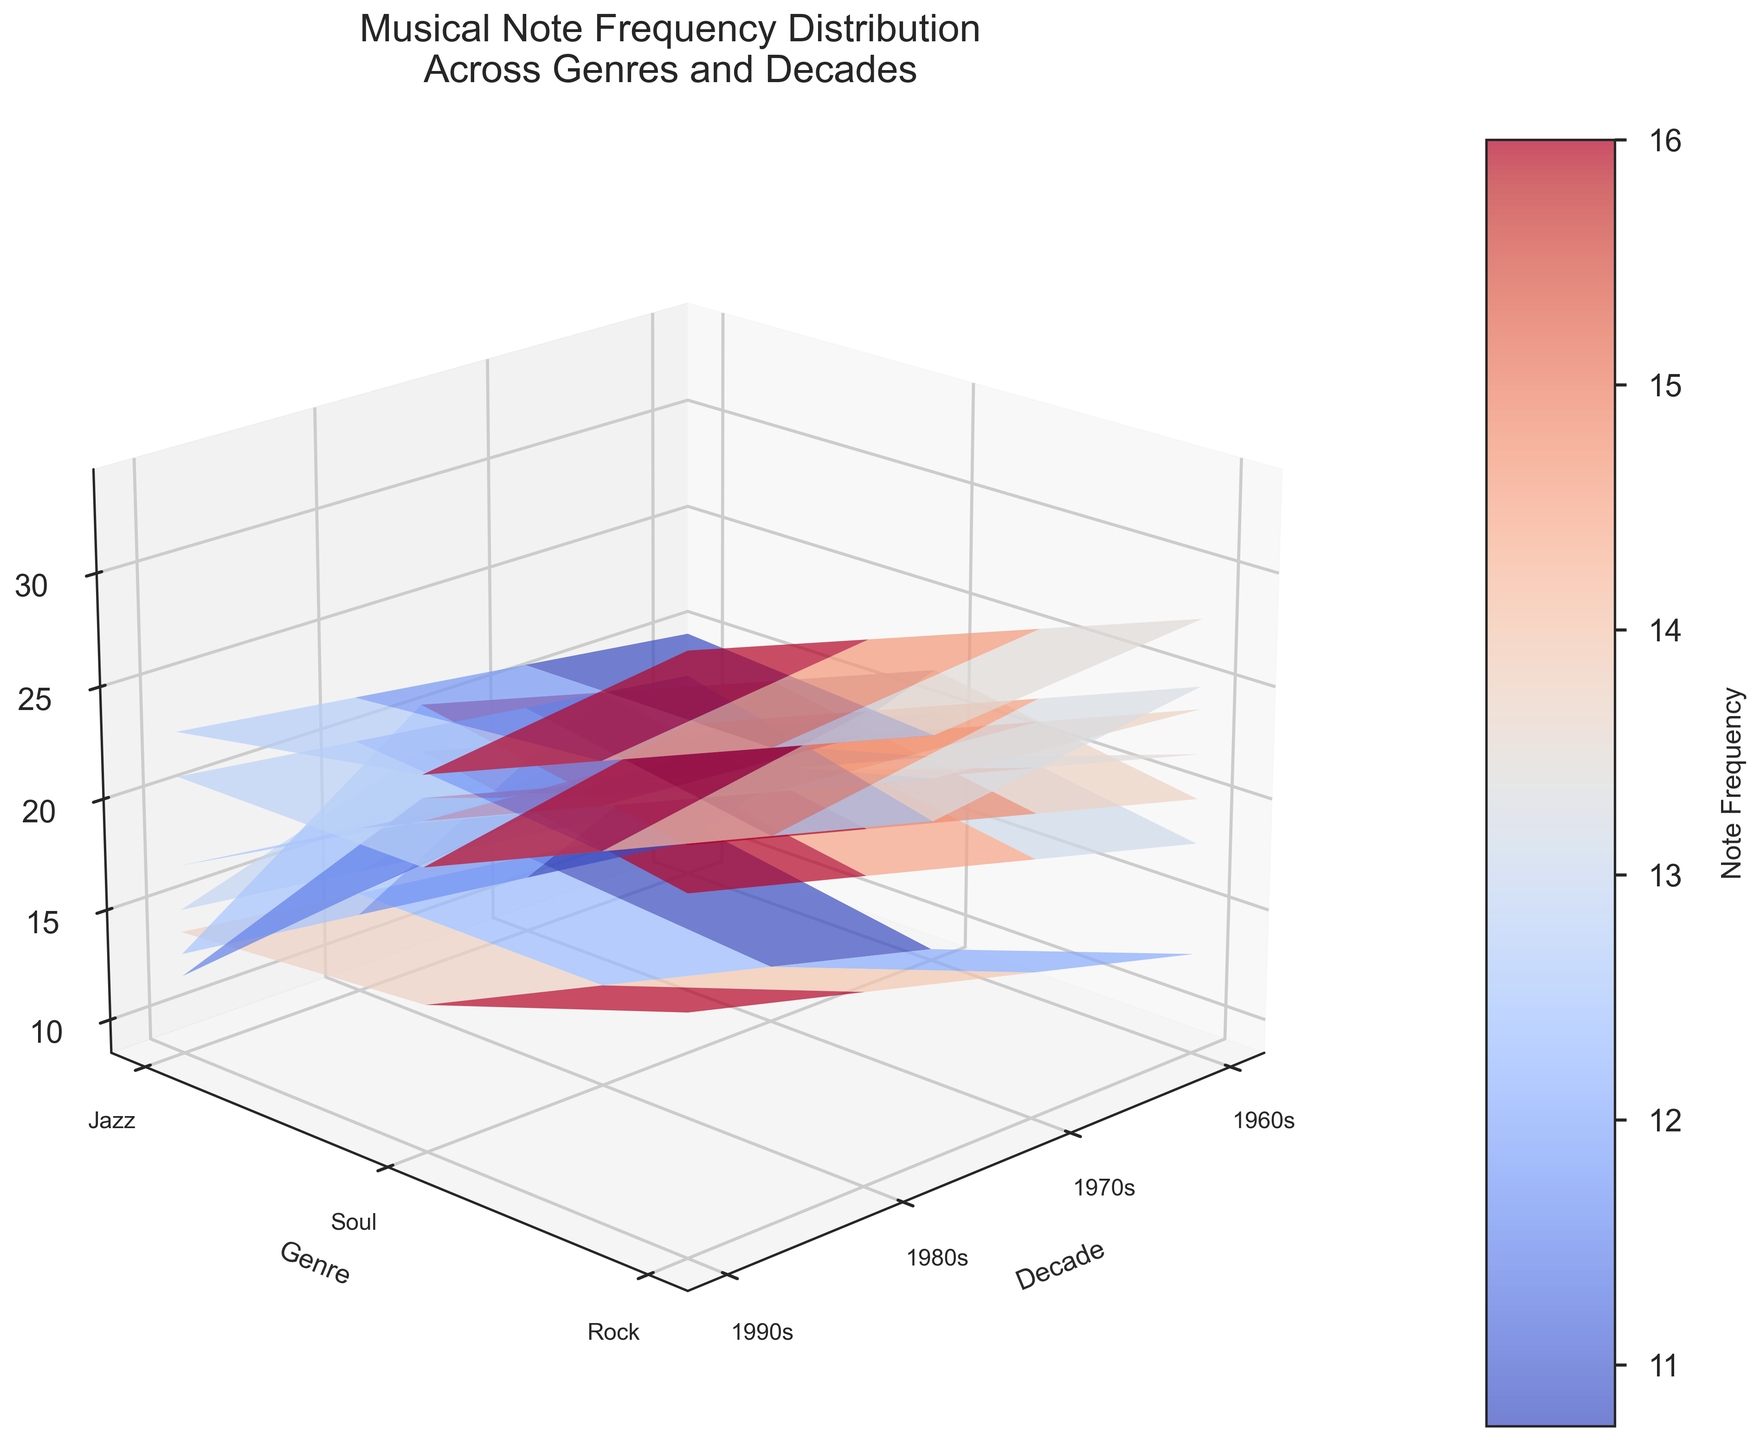What is the title of the figure? The title is usually positioned at the top of the figure. Here, it reads "Musical Note Frequency Distribution Across Genres and Decades".
Answer: Musical Note Frequency Distribution Across Genres and Decades Which genres are displayed in the figure? By looking at the y-axis labels, we can identify the genres. They include Jazz, Soul, and Rock.
Answer: Jazz, Soul, and Rock In which decade does the genre Jazz have the highest 'C' note frequency? By examining the section of the surface plot corresponding to Jazz, we find that the highest 'C' note frequency occurs in the 1960s.
Answer: 1960s How does the frequency of the 'A' note in Soul music change from the 1960s to the 1990s? By analyzing the change in the 'A' note frequencies for Soul across the years (24 in the 1960s, 26 in the 1970s, 28 in the 1980s, and 30 in the 1990s), we see a gradual increase.
Answer: Increases Which decade has the highest overall frequency for the 'G' note across all genres? We need to look at the surface corresponding to the 'G' note and identify which decade has the highest peaks across all genres. The highest frequency appears in the 1990s.
Answer: 1990s How does the frequency of the 'F' note in Rock music compare between the 1980s and the 1990s? By examining the 'F' note frequencies for Rock (26 in the 1980s and 28 in the 1990s), we can see that it increases slightly.
Answer: Increases Which note has the lowest frequency in the 1960s for Rock music? By looking at the frequencies for Rock in the 1960s, the 'B' note has the lowest at 9.
Answer: B What's the average frequency of 'E' note across all genres and decades? Summing the 'E' note frequency across all genres and decades (15+25+15+19+27+17+20+29+19+21+31+21) gives 259. There are 12 data points, thus the average is 259/12.
Answer: Approximately 21.58 In which genre and decade did the 'B' note reach the highest frequency? By examining the surface plot for the 'B' note clearly, we find the highest frequency is in the 1990s for Soul music.
Answer: Soul, 1990s 